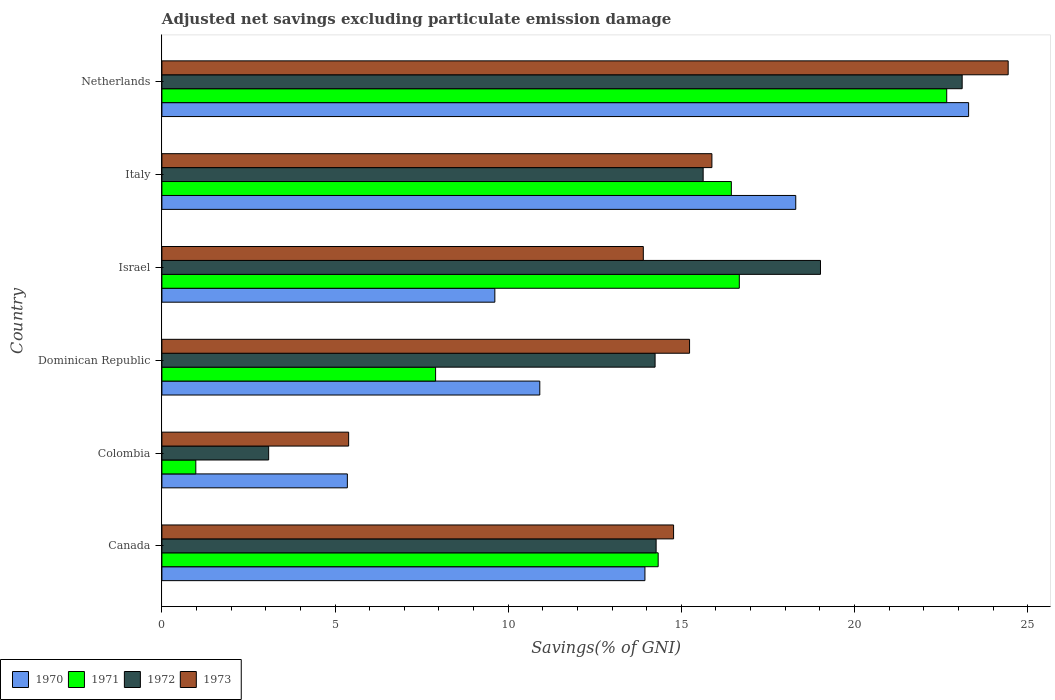How many different coloured bars are there?
Offer a terse response. 4. How many groups of bars are there?
Your answer should be compact. 6. Are the number of bars on each tick of the Y-axis equal?
Provide a short and direct response. Yes. How many bars are there on the 3rd tick from the top?
Make the answer very short. 4. How many bars are there on the 4th tick from the bottom?
Make the answer very short. 4. What is the label of the 3rd group of bars from the top?
Offer a terse response. Israel. What is the adjusted net savings in 1970 in Israel?
Your answer should be very brief. 9.61. Across all countries, what is the maximum adjusted net savings in 1971?
Provide a short and direct response. 22.66. Across all countries, what is the minimum adjusted net savings in 1972?
Provide a succinct answer. 3.08. In which country was the adjusted net savings in 1971 minimum?
Give a very brief answer. Colombia. What is the total adjusted net savings in 1970 in the graph?
Your answer should be very brief. 81.43. What is the difference between the adjusted net savings in 1970 in Canada and that in Netherlands?
Your response must be concise. -9.35. What is the difference between the adjusted net savings in 1970 in Dominican Republic and the adjusted net savings in 1972 in Netherlands?
Offer a terse response. -12.2. What is the average adjusted net savings in 1971 per country?
Your answer should be compact. 13.17. What is the difference between the adjusted net savings in 1972 and adjusted net savings in 1973 in Italy?
Ensure brevity in your answer.  -0.25. In how many countries, is the adjusted net savings in 1973 greater than 12 %?
Make the answer very short. 5. What is the ratio of the adjusted net savings in 1972 in Dominican Republic to that in Netherlands?
Offer a very short reply. 0.62. What is the difference between the highest and the second highest adjusted net savings in 1971?
Make the answer very short. 5.99. What is the difference between the highest and the lowest adjusted net savings in 1972?
Provide a short and direct response. 20.03. In how many countries, is the adjusted net savings in 1972 greater than the average adjusted net savings in 1972 taken over all countries?
Ensure brevity in your answer.  3. Is the sum of the adjusted net savings in 1971 in Dominican Republic and Italy greater than the maximum adjusted net savings in 1970 across all countries?
Offer a terse response. Yes. What does the 1st bar from the top in Israel represents?
Give a very brief answer. 1973. Are the values on the major ticks of X-axis written in scientific E-notation?
Your answer should be very brief. No. Does the graph contain any zero values?
Provide a short and direct response. No. Where does the legend appear in the graph?
Provide a succinct answer. Bottom left. How many legend labels are there?
Provide a succinct answer. 4. How are the legend labels stacked?
Your answer should be compact. Horizontal. What is the title of the graph?
Offer a very short reply. Adjusted net savings excluding particulate emission damage. What is the label or title of the X-axis?
Your response must be concise. Savings(% of GNI). What is the Savings(% of GNI) of 1970 in Canada?
Ensure brevity in your answer.  13.95. What is the Savings(% of GNI) of 1971 in Canada?
Keep it short and to the point. 14.33. What is the Savings(% of GNI) of 1972 in Canada?
Provide a succinct answer. 14.27. What is the Savings(% of GNI) in 1973 in Canada?
Your answer should be compact. 14.78. What is the Savings(% of GNI) of 1970 in Colombia?
Offer a terse response. 5.36. What is the Savings(% of GNI) of 1971 in Colombia?
Give a very brief answer. 0.98. What is the Savings(% of GNI) in 1972 in Colombia?
Ensure brevity in your answer.  3.08. What is the Savings(% of GNI) in 1973 in Colombia?
Your answer should be compact. 5.39. What is the Savings(% of GNI) in 1970 in Dominican Republic?
Offer a very short reply. 10.91. What is the Savings(% of GNI) of 1971 in Dominican Republic?
Offer a terse response. 7.9. What is the Savings(% of GNI) in 1972 in Dominican Republic?
Give a very brief answer. 14.24. What is the Savings(% of GNI) of 1973 in Dominican Republic?
Provide a succinct answer. 15.24. What is the Savings(% of GNI) of 1970 in Israel?
Provide a succinct answer. 9.61. What is the Savings(% of GNI) of 1971 in Israel?
Your answer should be very brief. 16.67. What is the Savings(% of GNI) of 1972 in Israel?
Give a very brief answer. 19.02. What is the Savings(% of GNI) in 1973 in Israel?
Offer a terse response. 13.9. What is the Savings(% of GNI) in 1970 in Italy?
Keep it short and to the point. 18.3. What is the Savings(% of GNI) in 1971 in Italy?
Provide a short and direct response. 16.44. What is the Savings(% of GNI) in 1972 in Italy?
Provide a short and direct response. 15.63. What is the Savings(% of GNI) in 1973 in Italy?
Your answer should be compact. 15.88. What is the Savings(% of GNI) in 1970 in Netherlands?
Offer a terse response. 23.3. What is the Savings(% of GNI) in 1971 in Netherlands?
Make the answer very short. 22.66. What is the Savings(% of GNI) of 1972 in Netherlands?
Ensure brevity in your answer.  23.11. What is the Savings(% of GNI) in 1973 in Netherlands?
Your answer should be very brief. 24.44. Across all countries, what is the maximum Savings(% of GNI) in 1970?
Make the answer very short. 23.3. Across all countries, what is the maximum Savings(% of GNI) in 1971?
Ensure brevity in your answer.  22.66. Across all countries, what is the maximum Savings(% of GNI) in 1972?
Offer a very short reply. 23.11. Across all countries, what is the maximum Savings(% of GNI) of 1973?
Provide a succinct answer. 24.44. Across all countries, what is the minimum Savings(% of GNI) in 1970?
Provide a succinct answer. 5.36. Across all countries, what is the minimum Savings(% of GNI) of 1971?
Your answer should be compact. 0.98. Across all countries, what is the minimum Savings(% of GNI) of 1972?
Provide a short and direct response. 3.08. Across all countries, what is the minimum Savings(% of GNI) in 1973?
Your answer should be compact. 5.39. What is the total Savings(% of GNI) of 1970 in the graph?
Keep it short and to the point. 81.43. What is the total Savings(% of GNI) in 1971 in the graph?
Keep it short and to the point. 79. What is the total Savings(% of GNI) in 1972 in the graph?
Provide a succinct answer. 89.35. What is the total Savings(% of GNI) of 1973 in the graph?
Your response must be concise. 89.63. What is the difference between the Savings(% of GNI) of 1970 in Canada and that in Colombia?
Provide a succinct answer. 8.59. What is the difference between the Savings(% of GNI) of 1971 in Canada and that in Colombia?
Offer a terse response. 13.35. What is the difference between the Savings(% of GNI) of 1972 in Canada and that in Colombia?
Make the answer very short. 11.19. What is the difference between the Savings(% of GNI) of 1973 in Canada and that in Colombia?
Provide a succinct answer. 9.38. What is the difference between the Savings(% of GNI) in 1970 in Canada and that in Dominican Republic?
Ensure brevity in your answer.  3.04. What is the difference between the Savings(% of GNI) in 1971 in Canada and that in Dominican Republic?
Provide a short and direct response. 6.43. What is the difference between the Savings(% of GNI) of 1972 in Canada and that in Dominican Republic?
Your answer should be compact. 0.03. What is the difference between the Savings(% of GNI) in 1973 in Canada and that in Dominican Republic?
Provide a short and direct response. -0.46. What is the difference between the Savings(% of GNI) of 1970 in Canada and that in Israel?
Keep it short and to the point. 4.33. What is the difference between the Savings(% of GNI) of 1971 in Canada and that in Israel?
Your response must be concise. -2.34. What is the difference between the Savings(% of GNI) in 1972 in Canada and that in Israel?
Provide a succinct answer. -4.75. What is the difference between the Savings(% of GNI) of 1973 in Canada and that in Israel?
Give a very brief answer. 0.87. What is the difference between the Savings(% of GNI) in 1970 in Canada and that in Italy?
Provide a succinct answer. -4.36. What is the difference between the Savings(% of GNI) in 1971 in Canada and that in Italy?
Provide a succinct answer. -2.11. What is the difference between the Savings(% of GNI) in 1972 in Canada and that in Italy?
Provide a succinct answer. -1.36. What is the difference between the Savings(% of GNI) of 1973 in Canada and that in Italy?
Your answer should be compact. -1.11. What is the difference between the Savings(% of GNI) of 1970 in Canada and that in Netherlands?
Make the answer very short. -9.35. What is the difference between the Savings(% of GNI) in 1971 in Canada and that in Netherlands?
Keep it short and to the point. -8.33. What is the difference between the Savings(% of GNI) of 1972 in Canada and that in Netherlands?
Your answer should be very brief. -8.84. What is the difference between the Savings(% of GNI) in 1973 in Canada and that in Netherlands?
Ensure brevity in your answer.  -9.66. What is the difference between the Savings(% of GNI) of 1970 in Colombia and that in Dominican Republic?
Provide a succinct answer. -5.56. What is the difference between the Savings(% of GNI) of 1971 in Colombia and that in Dominican Republic?
Provide a short and direct response. -6.92. What is the difference between the Savings(% of GNI) of 1972 in Colombia and that in Dominican Republic?
Your response must be concise. -11.16. What is the difference between the Savings(% of GNI) of 1973 in Colombia and that in Dominican Republic?
Ensure brevity in your answer.  -9.85. What is the difference between the Savings(% of GNI) in 1970 in Colombia and that in Israel?
Give a very brief answer. -4.26. What is the difference between the Savings(% of GNI) in 1971 in Colombia and that in Israel?
Keep it short and to the point. -15.7. What is the difference between the Savings(% of GNI) of 1972 in Colombia and that in Israel?
Your response must be concise. -15.94. What is the difference between the Savings(% of GNI) in 1973 in Colombia and that in Israel?
Offer a very short reply. -8.51. What is the difference between the Savings(% of GNI) of 1970 in Colombia and that in Italy?
Provide a short and direct response. -12.95. What is the difference between the Savings(% of GNI) in 1971 in Colombia and that in Italy?
Provide a short and direct response. -15.46. What is the difference between the Savings(% of GNI) in 1972 in Colombia and that in Italy?
Make the answer very short. -12.55. What is the difference between the Savings(% of GNI) of 1973 in Colombia and that in Italy?
Your answer should be compact. -10.49. What is the difference between the Savings(% of GNI) of 1970 in Colombia and that in Netherlands?
Make the answer very short. -17.94. What is the difference between the Savings(% of GNI) in 1971 in Colombia and that in Netherlands?
Make the answer very short. -21.68. What is the difference between the Savings(% of GNI) in 1972 in Colombia and that in Netherlands?
Keep it short and to the point. -20.03. What is the difference between the Savings(% of GNI) of 1973 in Colombia and that in Netherlands?
Make the answer very short. -19.05. What is the difference between the Savings(% of GNI) in 1970 in Dominican Republic and that in Israel?
Provide a succinct answer. 1.3. What is the difference between the Savings(% of GNI) in 1971 in Dominican Republic and that in Israel?
Keep it short and to the point. -8.77. What is the difference between the Savings(% of GNI) in 1972 in Dominican Republic and that in Israel?
Your answer should be very brief. -4.78. What is the difference between the Savings(% of GNI) of 1973 in Dominican Republic and that in Israel?
Your answer should be compact. 1.34. What is the difference between the Savings(% of GNI) in 1970 in Dominican Republic and that in Italy?
Your response must be concise. -7.39. What is the difference between the Savings(% of GNI) of 1971 in Dominican Republic and that in Italy?
Keep it short and to the point. -8.54. What is the difference between the Savings(% of GNI) of 1972 in Dominican Republic and that in Italy?
Your answer should be very brief. -1.39. What is the difference between the Savings(% of GNI) of 1973 in Dominican Republic and that in Italy?
Offer a terse response. -0.65. What is the difference between the Savings(% of GNI) in 1970 in Dominican Republic and that in Netherlands?
Keep it short and to the point. -12.38. What is the difference between the Savings(% of GNI) of 1971 in Dominican Republic and that in Netherlands?
Ensure brevity in your answer.  -14.76. What is the difference between the Savings(% of GNI) of 1972 in Dominican Republic and that in Netherlands?
Your response must be concise. -8.87. What is the difference between the Savings(% of GNI) in 1973 in Dominican Republic and that in Netherlands?
Ensure brevity in your answer.  -9.2. What is the difference between the Savings(% of GNI) in 1970 in Israel and that in Italy?
Give a very brief answer. -8.69. What is the difference between the Savings(% of GNI) in 1971 in Israel and that in Italy?
Offer a very short reply. 0.23. What is the difference between the Savings(% of GNI) of 1972 in Israel and that in Italy?
Keep it short and to the point. 3.39. What is the difference between the Savings(% of GNI) in 1973 in Israel and that in Italy?
Offer a terse response. -1.98. What is the difference between the Savings(% of GNI) in 1970 in Israel and that in Netherlands?
Your answer should be very brief. -13.68. What is the difference between the Savings(% of GNI) of 1971 in Israel and that in Netherlands?
Keep it short and to the point. -5.99. What is the difference between the Savings(% of GNI) of 1972 in Israel and that in Netherlands?
Make the answer very short. -4.09. What is the difference between the Savings(% of GNI) of 1973 in Israel and that in Netherlands?
Give a very brief answer. -10.54. What is the difference between the Savings(% of GNI) in 1970 in Italy and that in Netherlands?
Provide a short and direct response. -4.99. What is the difference between the Savings(% of GNI) in 1971 in Italy and that in Netherlands?
Your answer should be very brief. -6.22. What is the difference between the Savings(% of GNI) in 1972 in Italy and that in Netherlands?
Ensure brevity in your answer.  -7.48. What is the difference between the Savings(% of GNI) in 1973 in Italy and that in Netherlands?
Give a very brief answer. -8.56. What is the difference between the Savings(% of GNI) in 1970 in Canada and the Savings(% of GNI) in 1971 in Colombia?
Offer a very short reply. 12.97. What is the difference between the Savings(% of GNI) of 1970 in Canada and the Savings(% of GNI) of 1972 in Colombia?
Offer a very short reply. 10.87. What is the difference between the Savings(% of GNI) in 1970 in Canada and the Savings(% of GNI) in 1973 in Colombia?
Provide a short and direct response. 8.56. What is the difference between the Savings(% of GNI) in 1971 in Canada and the Savings(% of GNI) in 1972 in Colombia?
Provide a short and direct response. 11.25. What is the difference between the Savings(% of GNI) in 1971 in Canada and the Savings(% of GNI) in 1973 in Colombia?
Provide a succinct answer. 8.94. What is the difference between the Savings(% of GNI) in 1972 in Canada and the Savings(% of GNI) in 1973 in Colombia?
Your answer should be compact. 8.88. What is the difference between the Savings(% of GNI) in 1970 in Canada and the Savings(% of GNI) in 1971 in Dominican Republic?
Your answer should be compact. 6.05. What is the difference between the Savings(% of GNI) of 1970 in Canada and the Savings(% of GNI) of 1972 in Dominican Republic?
Your answer should be very brief. -0.29. What is the difference between the Savings(% of GNI) in 1970 in Canada and the Savings(% of GNI) in 1973 in Dominican Republic?
Keep it short and to the point. -1.29. What is the difference between the Savings(% of GNI) in 1971 in Canada and the Savings(% of GNI) in 1972 in Dominican Republic?
Provide a succinct answer. 0.09. What is the difference between the Savings(% of GNI) of 1971 in Canada and the Savings(% of GNI) of 1973 in Dominican Republic?
Make the answer very short. -0.91. What is the difference between the Savings(% of GNI) of 1972 in Canada and the Savings(% of GNI) of 1973 in Dominican Republic?
Offer a very short reply. -0.97. What is the difference between the Savings(% of GNI) of 1970 in Canada and the Savings(% of GNI) of 1971 in Israel?
Offer a terse response. -2.73. What is the difference between the Savings(% of GNI) of 1970 in Canada and the Savings(% of GNI) of 1972 in Israel?
Offer a terse response. -5.07. What is the difference between the Savings(% of GNI) of 1970 in Canada and the Savings(% of GNI) of 1973 in Israel?
Provide a short and direct response. 0.05. What is the difference between the Savings(% of GNI) in 1971 in Canada and the Savings(% of GNI) in 1972 in Israel?
Make the answer very short. -4.69. What is the difference between the Savings(% of GNI) of 1971 in Canada and the Savings(% of GNI) of 1973 in Israel?
Give a very brief answer. 0.43. What is the difference between the Savings(% of GNI) of 1972 in Canada and the Savings(% of GNI) of 1973 in Israel?
Provide a succinct answer. 0.37. What is the difference between the Savings(% of GNI) in 1970 in Canada and the Savings(% of GNI) in 1971 in Italy?
Make the answer very short. -2.5. What is the difference between the Savings(% of GNI) of 1970 in Canada and the Savings(% of GNI) of 1972 in Italy?
Your response must be concise. -1.68. What is the difference between the Savings(% of GNI) of 1970 in Canada and the Savings(% of GNI) of 1973 in Italy?
Give a very brief answer. -1.93. What is the difference between the Savings(% of GNI) of 1971 in Canada and the Savings(% of GNI) of 1972 in Italy?
Ensure brevity in your answer.  -1.3. What is the difference between the Savings(% of GNI) of 1971 in Canada and the Savings(% of GNI) of 1973 in Italy?
Keep it short and to the point. -1.55. What is the difference between the Savings(% of GNI) of 1972 in Canada and the Savings(% of GNI) of 1973 in Italy?
Provide a short and direct response. -1.61. What is the difference between the Savings(% of GNI) of 1970 in Canada and the Savings(% of GNI) of 1971 in Netherlands?
Provide a short and direct response. -8.71. What is the difference between the Savings(% of GNI) of 1970 in Canada and the Savings(% of GNI) of 1972 in Netherlands?
Your response must be concise. -9.16. What is the difference between the Savings(% of GNI) of 1970 in Canada and the Savings(% of GNI) of 1973 in Netherlands?
Keep it short and to the point. -10.49. What is the difference between the Savings(% of GNI) in 1971 in Canada and the Savings(% of GNI) in 1972 in Netherlands?
Your answer should be compact. -8.78. What is the difference between the Savings(% of GNI) of 1971 in Canada and the Savings(% of GNI) of 1973 in Netherlands?
Provide a short and direct response. -10.11. What is the difference between the Savings(% of GNI) of 1972 in Canada and the Savings(% of GNI) of 1973 in Netherlands?
Your answer should be very brief. -10.17. What is the difference between the Savings(% of GNI) of 1970 in Colombia and the Savings(% of GNI) of 1971 in Dominican Republic?
Ensure brevity in your answer.  -2.55. What is the difference between the Savings(% of GNI) of 1970 in Colombia and the Savings(% of GNI) of 1972 in Dominican Republic?
Offer a terse response. -8.89. What is the difference between the Savings(% of GNI) in 1970 in Colombia and the Savings(% of GNI) in 1973 in Dominican Republic?
Give a very brief answer. -9.88. What is the difference between the Savings(% of GNI) of 1971 in Colombia and the Savings(% of GNI) of 1972 in Dominican Republic?
Ensure brevity in your answer.  -13.26. What is the difference between the Savings(% of GNI) of 1971 in Colombia and the Savings(% of GNI) of 1973 in Dominican Republic?
Give a very brief answer. -14.26. What is the difference between the Savings(% of GNI) in 1972 in Colombia and the Savings(% of GNI) in 1973 in Dominican Republic?
Provide a short and direct response. -12.15. What is the difference between the Savings(% of GNI) in 1970 in Colombia and the Savings(% of GNI) in 1971 in Israel?
Offer a terse response. -11.32. What is the difference between the Savings(% of GNI) of 1970 in Colombia and the Savings(% of GNI) of 1972 in Israel?
Your response must be concise. -13.66. What is the difference between the Savings(% of GNI) of 1970 in Colombia and the Savings(% of GNI) of 1973 in Israel?
Your response must be concise. -8.55. What is the difference between the Savings(% of GNI) of 1971 in Colombia and the Savings(% of GNI) of 1972 in Israel?
Your response must be concise. -18.04. What is the difference between the Savings(% of GNI) in 1971 in Colombia and the Savings(% of GNI) in 1973 in Israel?
Provide a succinct answer. -12.92. What is the difference between the Savings(% of GNI) in 1972 in Colombia and the Savings(% of GNI) in 1973 in Israel?
Your answer should be very brief. -10.82. What is the difference between the Savings(% of GNI) in 1970 in Colombia and the Savings(% of GNI) in 1971 in Italy?
Offer a terse response. -11.09. What is the difference between the Savings(% of GNI) of 1970 in Colombia and the Savings(% of GNI) of 1972 in Italy?
Your answer should be compact. -10.27. What is the difference between the Savings(% of GNI) of 1970 in Colombia and the Savings(% of GNI) of 1973 in Italy?
Your response must be concise. -10.53. What is the difference between the Savings(% of GNI) in 1971 in Colombia and the Savings(% of GNI) in 1972 in Italy?
Make the answer very short. -14.65. What is the difference between the Savings(% of GNI) of 1971 in Colombia and the Savings(% of GNI) of 1973 in Italy?
Keep it short and to the point. -14.9. What is the difference between the Savings(% of GNI) in 1972 in Colombia and the Savings(% of GNI) in 1973 in Italy?
Give a very brief answer. -12.8. What is the difference between the Savings(% of GNI) in 1970 in Colombia and the Savings(% of GNI) in 1971 in Netherlands?
Keep it short and to the point. -17.31. What is the difference between the Savings(% of GNI) of 1970 in Colombia and the Savings(% of GNI) of 1972 in Netherlands?
Your answer should be very brief. -17.75. What is the difference between the Savings(% of GNI) in 1970 in Colombia and the Savings(% of GNI) in 1973 in Netherlands?
Give a very brief answer. -19.08. What is the difference between the Savings(% of GNI) in 1971 in Colombia and the Savings(% of GNI) in 1972 in Netherlands?
Offer a very short reply. -22.13. What is the difference between the Savings(% of GNI) in 1971 in Colombia and the Savings(% of GNI) in 1973 in Netherlands?
Give a very brief answer. -23.46. What is the difference between the Savings(% of GNI) of 1972 in Colombia and the Savings(% of GNI) of 1973 in Netherlands?
Provide a short and direct response. -21.36. What is the difference between the Savings(% of GNI) of 1970 in Dominican Republic and the Savings(% of GNI) of 1971 in Israel?
Give a very brief answer. -5.76. What is the difference between the Savings(% of GNI) in 1970 in Dominican Republic and the Savings(% of GNI) in 1972 in Israel?
Your answer should be very brief. -8.11. What is the difference between the Savings(% of GNI) of 1970 in Dominican Republic and the Savings(% of GNI) of 1973 in Israel?
Your response must be concise. -2.99. What is the difference between the Savings(% of GNI) of 1971 in Dominican Republic and the Savings(% of GNI) of 1972 in Israel?
Provide a succinct answer. -11.11. What is the difference between the Savings(% of GNI) in 1971 in Dominican Republic and the Savings(% of GNI) in 1973 in Israel?
Give a very brief answer. -6. What is the difference between the Savings(% of GNI) in 1972 in Dominican Republic and the Savings(% of GNI) in 1973 in Israel?
Provide a short and direct response. 0.34. What is the difference between the Savings(% of GNI) in 1970 in Dominican Republic and the Savings(% of GNI) in 1971 in Italy?
Ensure brevity in your answer.  -5.53. What is the difference between the Savings(% of GNI) in 1970 in Dominican Republic and the Savings(% of GNI) in 1972 in Italy?
Make the answer very short. -4.72. What is the difference between the Savings(% of GNI) of 1970 in Dominican Republic and the Savings(% of GNI) of 1973 in Italy?
Provide a short and direct response. -4.97. What is the difference between the Savings(% of GNI) in 1971 in Dominican Republic and the Savings(% of GNI) in 1972 in Italy?
Keep it short and to the point. -7.73. What is the difference between the Savings(% of GNI) in 1971 in Dominican Republic and the Savings(% of GNI) in 1973 in Italy?
Ensure brevity in your answer.  -7.98. What is the difference between the Savings(% of GNI) in 1972 in Dominican Republic and the Savings(% of GNI) in 1973 in Italy?
Give a very brief answer. -1.64. What is the difference between the Savings(% of GNI) in 1970 in Dominican Republic and the Savings(% of GNI) in 1971 in Netherlands?
Your answer should be compact. -11.75. What is the difference between the Savings(% of GNI) in 1970 in Dominican Republic and the Savings(% of GNI) in 1972 in Netherlands?
Your answer should be compact. -12.2. What is the difference between the Savings(% of GNI) in 1970 in Dominican Republic and the Savings(% of GNI) in 1973 in Netherlands?
Your answer should be compact. -13.53. What is the difference between the Savings(% of GNI) of 1971 in Dominican Republic and the Savings(% of GNI) of 1972 in Netherlands?
Your response must be concise. -15.21. What is the difference between the Savings(% of GNI) of 1971 in Dominican Republic and the Savings(% of GNI) of 1973 in Netherlands?
Provide a succinct answer. -16.53. What is the difference between the Savings(% of GNI) of 1972 in Dominican Republic and the Savings(% of GNI) of 1973 in Netherlands?
Keep it short and to the point. -10.2. What is the difference between the Savings(% of GNI) in 1970 in Israel and the Savings(% of GNI) in 1971 in Italy?
Your answer should be very brief. -6.83. What is the difference between the Savings(% of GNI) in 1970 in Israel and the Savings(% of GNI) in 1972 in Italy?
Your answer should be compact. -6.02. What is the difference between the Savings(% of GNI) in 1970 in Israel and the Savings(% of GNI) in 1973 in Italy?
Make the answer very short. -6.27. What is the difference between the Savings(% of GNI) of 1971 in Israel and the Savings(% of GNI) of 1972 in Italy?
Your response must be concise. 1.04. What is the difference between the Savings(% of GNI) of 1971 in Israel and the Savings(% of GNI) of 1973 in Italy?
Offer a very short reply. 0.79. What is the difference between the Savings(% of GNI) of 1972 in Israel and the Savings(% of GNI) of 1973 in Italy?
Ensure brevity in your answer.  3.14. What is the difference between the Savings(% of GNI) in 1970 in Israel and the Savings(% of GNI) in 1971 in Netherlands?
Offer a terse response. -13.05. What is the difference between the Savings(% of GNI) in 1970 in Israel and the Savings(% of GNI) in 1972 in Netherlands?
Provide a succinct answer. -13.49. What is the difference between the Savings(% of GNI) in 1970 in Israel and the Savings(% of GNI) in 1973 in Netherlands?
Provide a succinct answer. -14.82. What is the difference between the Savings(% of GNI) of 1971 in Israel and the Savings(% of GNI) of 1972 in Netherlands?
Ensure brevity in your answer.  -6.44. What is the difference between the Savings(% of GNI) in 1971 in Israel and the Savings(% of GNI) in 1973 in Netherlands?
Offer a very short reply. -7.76. What is the difference between the Savings(% of GNI) in 1972 in Israel and the Savings(% of GNI) in 1973 in Netherlands?
Ensure brevity in your answer.  -5.42. What is the difference between the Savings(% of GNI) in 1970 in Italy and the Savings(% of GNI) in 1971 in Netherlands?
Your response must be concise. -4.36. What is the difference between the Savings(% of GNI) in 1970 in Italy and the Savings(% of GNI) in 1972 in Netherlands?
Provide a short and direct response. -4.81. What is the difference between the Savings(% of GNI) in 1970 in Italy and the Savings(% of GNI) in 1973 in Netherlands?
Ensure brevity in your answer.  -6.13. What is the difference between the Savings(% of GNI) of 1971 in Italy and the Savings(% of GNI) of 1972 in Netherlands?
Provide a succinct answer. -6.67. What is the difference between the Savings(% of GNI) in 1971 in Italy and the Savings(% of GNI) in 1973 in Netherlands?
Give a very brief answer. -7.99. What is the difference between the Savings(% of GNI) in 1972 in Italy and the Savings(% of GNI) in 1973 in Netherlands?
Offer a terse response. -8.81. What is the average Savings(% of GNI) in 1970 per country?
Give a very brief answer. 13.57. What is the average Savings(% of GNI) of 1971 per country?
Provide a succinct answer. 13.17. What is the average Savings(% of GNI) of 1972 per country?
Offer a terse response. 14.89. What is the average Savings(% of GNI) in 1973 per country?
Ensure brevity in your answer.  14.94. What is the difference between the Savings(% of GNI) in 1970 and Savings(% of GNI) in 1971 in Canada?
Your answer should be very brief. -0.38. What is the difference between the Savings(% of GNI) in 1970 and Savings(% of GNI) in 1972 in Canada?
Offer a terse response. -0.32. What is the difference between the Savings(% of GNI) of 1970 and Savings(% of GNI) of 1973 in Canada?
Provide a succinct answer. -0.83. What is the difference between the Savings(% of GNI) of 1971 and Savings(% of GNI) of 1972 in Canada?
Keep it short and to the point. 0.06. What is the difference between the Savings(% of GNI) in 1971 and Savings(% of GNI) in 1973 in Canada?
Your answer should be compact. -0.45. What is the difference between the Savings(% of GNI) of 1972 and Savings(% of GNI) of 1973 in Canada?
Your response must be concise. -0.5. What is the difference between the Savings(% of GNI) in 1970 and Savings(% of GNI) in 1971 in Colombia?
Offer a terse response. 4.38. What is the difference between the Savings(% of GNI) of 1970 and Savings(% of GNI) of 1972 in Colombia?
Offer a terse response. 2.27. What is the difference between the Savings(% of GNI) in 1970 and Savings(% of GNI) in 1973 in Colombia?
Offer a very short reply. -0.04. What is the difference between the Savings(% of GNI) of 1971 and Savings(% of GNI) of 1972 in Colombia?
Provide a short and direct response. -2.1. What is the difference between the Savings(% of GNI) of 1971 and Savings(% of GNI) of 1973 in Colombia?
Give a very brief answer. -4.41. What is the difference between the Savings(% of GNI) of 1972 and Savings(% of GNI) of 1973 in Colombia?
Offer a terse response. -2.31. What is the difference between the Savings(% of GNI) of 1970 and Savings(% of GNI) of 1971 in Dominican Republic?
Provide a succinct answer. 3.01. What is the difference between the Savings(% of GNI) in 1970 and Savings(% of GNI) in 1972 in Dominican Republic?
Make the answer very short. -3.33. What is the difference between the Savings(% of GNI) in 1970 and Savings(% of GNI) in 1973 in Dominican Republic?
Make the answer very short. -4.33. What is the difference between the Savings(% of GNI) of 1971 and Savings(% of GNI) of 1972 in Dominican Republic?
Provide a succinct answer. -6.34. What is the difference between the Savings(% of GNI) of 1971 and Savings(% of GNI) of 1973 in Dominican Republic?
Your response must be concise. -7.33. What is the difference between the Savings(% of GNI) of 1972 and Savings(% of GNI) of 1973 in Dominican Republic?
Your answer should be very brief. -1. What is the difference between the Savings(% of GNI) of 1970 and Savings(% of GNI) of 1971 in Israel?
Provide a short and direct response. -7.06. What is the difference between the Savings(% of GNI) of 1970 and Savings(% of GNI) of 1972 in Israel?
Offer a very short reply. -9.4. What is the difference between the Savings(% of GNI) of 1970 and Savings(% of GNI) of 1973 in Israel?
Your answer should be compact. -4.29. What is the difference between the Savings(% of GNI) of 1971 and Savings(% of GNI) of 1972 in Israel?
Make the answer very short. -2.34. What is the difference between the Savings(% of GNI) of 1971 and Savings(% of GNI) of 1973 in Israel?
Your response must be concise. 2.77. What is the difference between the Savings(% of GNI) in 1972 and Savings(% of GNI) in 1973 in Israel?
Offer a very short reply. 5.12. What is the difference between the Savings(% of GNI) of 1970 and Savings(% of GNI) of 1971 in Italy?
Provide a succinct answer. 1.86. What is the difference between the Savings(% of GNI) in 1970 and Savings(% of GNI) in 1972 in Italy?
Your response must be concise. 2.67. What is the difference between the Savings(% of GNI) in 1970 and Savings(% of GNI) in 1973 in Italy?
Provide a succinct answer. 2.42. What is the difference between the Savings(% of GNI) of 1971 and Savings(% of GNI) of 1972 in Italy?
Make the answer very short. 0.81. What is the difference between the Savings(% of GNI) of 1971 and Savings(% of GNI) of 1973 in Italy?
Your answer should be compact. 0.56. What is the difference between the Savings(% of GNI) in 1972 and Savings(% of GNI) in 1973 in Italy?
Your answer should be very brief. -0.25. What is the difference between the Savings(% of GNI) in 1970 and Savings(% of GNI) in 1971 in Netherlands?
Your response must be concise. 0.63. What is the difference between the Savings(% of GNI) in 1970 and Savings(% of GNI) in 1972 in Netherlands?
Your answer should be compact. 0.19. What is the difference between the Savings(% of GNI) in 1970 and Savings(% of GNI) in 1973 in Netherlands?
Your answer should be very brief. -1.14. What is the difference between the Savings(% of GNI) of 1971 and Savings(% of GNI) of 1972 in Netherlands?
Keep it short and to the point. -0.45. What is the difference between the Savings(% of GNI) in 1971 and Savings(% of GNI) in 1973 in Netherlands?
Your response must be concise. -1.77. What is the difference between the Savings(% of GNI) in 1972 and Savings(% of GNI) in 1973 in Netherlands?
Offer a very short reply. -1.33. What is the ratio of the Savings(% of GNI) of 1970 in Canada to that in Colombia?
Give a very brief answer. 2.6. What is the ratio of the Savings(% of GNI) of 1971 in Canada to that in Colombia?
Provide a short and direct response. 14.64. What is the ratio of the Savings(% of GNI) of 1972 in Canada to that in Colombia?
Offer a terse response. 4.63. What is the ratio of the Savings(% of GNI) of 1973 in Canada to that in Colombia?
Ensure brevity in your answer.  2.74. What is the ratio of the Savings(% of GNI) of 1970 in Canada to that in Dominican Republic?
Make the answer very short. 1.28. What is the ratio of the Savings(% of GNI) of 1971 in Canada to that in Dominican Republic?
Your response must be concise. 1.81. What is the ratio of the Savings(% of GNI) of 1973 in Canada to that in Dominican Republic?
Your response must be concise. 0.97. What is the ratio of the Savings(% of GNI) in 1970 in Canada to that in Israel?
Provide a succinct answer. 1.45. What is the ratio of the Savings(% of GNI) of 1971 in Canada to that in Israel?
Make the answer very short. 0.86. What is the ratio of the Savings(% of GNI) in 1972 in Canada to that in Israel?
Make the answer very short. 0.75. What is the ratio of the Savings(% of GNI) of 1973 in Canada to that in Israel?
Ensure brevity in your answer.  1.06. What is the ratio of the Savings(% of GNI) of 1970 in Canada to that in Italy?
Offer a terse response. 0.76. What is the ratio of the Savings(% of GNI) of 1971 in Canada to that in Italy?
Your response must be concise. 0.87. What is the ratio of the Savings(% of GNI) of 1972 in Canada to that in Italy?
Provide a short and direct response. 0.91. What is the ratio of the Savings(% of GNI) in 1973 in Canada to that in Italy?
Your response must be concise. 0.93. What is the ratio of the Savings(% of GNI) in 1970 in Canada to that in Netherlands?
Your response must be concise. 0.6. What is the ratio of the Savings(% of GNI) in 1971 in Canada to that in Netherlands?
Your answer should be compact. 0.63. What is the ratio of the Savings(% of GNI) in 1972 in Canada to that in Netherlands?
Ensure brevity in your answer.  0.62. What is the ratio of the Savings(% of GNI) in 1973 in Canada to that in Netherlands?
Offer a very short reply. 0.6. What is the ratio of the Savings(% of GNI) in 1970 in Colombia to that in Dominican Republic?
Give a very brief answer. 0.49. What is the ratio of the Savings(% of GNI) in 1971 in Colombia to that in Dominican Republic?
Offer a very short reply. 0.12. What is the ratio of the Savings(% of GNI) of 1972 in Colombia to that in Dominican Republic?
Your answer should be compact. 0.22. What is the ratio of the Savings(% of GNI) in 1973 in Colombia to that in Dominican Republic?
Provide a short and direct response. 0.35. What is the ratio of the Savings(% of GNI) in 1970 in Colombia to that in Israel?
Make the answer very short. 0.56. What is the ratio of the Savings(% of GNI) in 1971 in Colombia to that in Israel?
Ensure brevity in your answer.  0.06. What is the ratio of the Savings(% of GNI) in 1972 in Colombia to that in Israel?
Make the answer very short. 0.16. What is the ratio of the Savings(% of GNI) in 1973 in Colombia to that in Israel?
Ensure brevity in your answer.  0.39. What is the ratio of the Savings(% of GNI) in 1970 in Colombia to that in Italy?
Provide a short and direct response. 0.29. What is the ratio of the Savings(% of GNI) in 1971 in Colombia to that in Italy?
Your response must be concise. 0.06. What is the ratio of the Savings(% of GNI) in 1972 in Colombia to that in Italy?
Provide a short and direct response. 0.2. What is the ratio of the Savings(% of GNI) of 1973 in Colombia to that in Italy?
Offer a very short reply. 0.34. What is the ratio of the Savings(% of GNI) in 1970 in Colombia to that in Netherlands?
Your response must be concise. 0.23. What is the ratio of the Savings(% of GNI) in 1971 in Colombia to that in Netherlands?
Provide a short and direct response. 0.04. What is the ratio of the Savings(% of GNI) in 1972 in Colombia to that in Netherlands?
Offer a very short reply. 0.13. What is the ratio of the Savings(% of GNI) of 1973 in Colombia to that in Netherlands?
Your answer should be compact. 0.22. What is the ratio of the Savings(% of GNI) in 1970 in Dominican Republic to that in Israel?
Your answer should be very brief. 1.14. What is the ratio of the Savings(% of GNI) in 1971 in Dominican Republic to that in Israel?
Ensure brevity in your answer.  0.47. What is the ratio of the Savings(% of GNI) in 1972 in Dominican Republic to that in Israel?
Your answer should be compact. 0.75. What is the ratio of the Savings(% of GNI) in 1973 in Dominican Republic to that in Israel?
Offer a terse response. 1.1. What is the ratio of the Savings(% of GNI) in 1970 in Dominican Republic to that in Italy?
Offer a very short reply. 0.6. What is the ratio of the Savings(% of GNI) in 1971 in Dominican Republic to that in Italy?
Make the answer very short. 0.48. What is the ratio of the Savings(% of GNI) in 1972 in Dominican Republic to that in Italy?
Provide a short and direct response. 0.91. What is the ratio of the Savings(% of GNI) in 1973 in Dominican Republic to that in Italy?
Keep it short and to the point. 0.96. What is the ratio of the Savings(% of GNI) in 1970 in Dominican Republic to that in Netherlands?
Provide a succinct answer. 0.47. What is the ratio of the Savings(% of GNI) in 1971 in Dominican Republic to that in Netherlands?
Keep it short and to the point. 0.35. What is the ratio of the Savings(% of GNI) in 1972 in Dominican Republic to that in Netherlands?
Your answer should be very brief. 0.62. What is the ratio of the Savings(% of GNI) in 1973 in Dominican Republic to that in Netherlands?
Offer a very short reply. 0.62. What is the ratio of the Savings(% of GNI) in 1970 in Israel to that in Italy?
Give a very brief answer. 0.53. What is the ratio of the Savings(% of GNI) in 1972 in Israel to that in Italy?
Give a very brief answer. 1.22. What is the ratio of the Savings(% of GNI) in 1973 in Israel to that in Italy?
Make the answer very short. 0.88. What is the ratio of the Savings(% of GNI) of 1970 in Israel to that in Netherlands?
Your response must be concise. 0.41. What is the ratio of the Savings(% of GNI) in 1971 in Israel to that in Netherlands?
Offer a terse response. 0.74. What is the ratio of the Savings(% of GNI) in 1972 in Israel to that in Netherlands?
Your answer should be compact. 0.82. What is the ratio of the Savings(% of GNI) of 1973 in Israel to that in Netherlands?
Your answer should be compact. 0.57. What is the ratio of the Savings(% of GNI) of 1970 in Italy to that in Netherlands?
Provide a short and direct response. 0.79. What is the ratio of the Savings(% of GNI) in 1971 in Italy to that in Netherlands?
Ensure brevity in your answer.  0.73. What is the ratio of the Savings(% of GNI) in 1972 in Italy to that in Netherlands?
Your answer should be compact. 0.68. What is the ratio of the Savings(% of GNI) in 1973 in Italy to that in Netherlands?
Your answer should be compact. 0.65. What is the difference between the highest and the second highest Savings(% of GNI) of 1970?
Make the answer very short. 4.99. What is the difference between the highest and the second highest Savings(% of GNI) of 1971?
Your answer should be very brief. 5.99. What is the difference between the highest and the second highest Savings(% of GNI) of 1972?
Provide a short and direct response. 4.09. What is the difference between the highest and the second highest Savings(% of GNI) in 1973?
Provide a short and direct response. 8.56. What is the difference between the highest and the lowest Savings(% of GNI) in 1970?
Your response must be concise. 17.94. What is the difference between the highest and the lowest Savings(% of GNI) of 1971?
Ensure brevity in your answer.  21.68. What is the difference between the highest and the lowest Savings(% of GNI) in 1972?
Your answer should be very brief. 20.03. What is the difference between the highest and the lowest Savings(% of GNI) of 1973?
Give a very brief answer. 19.05. 